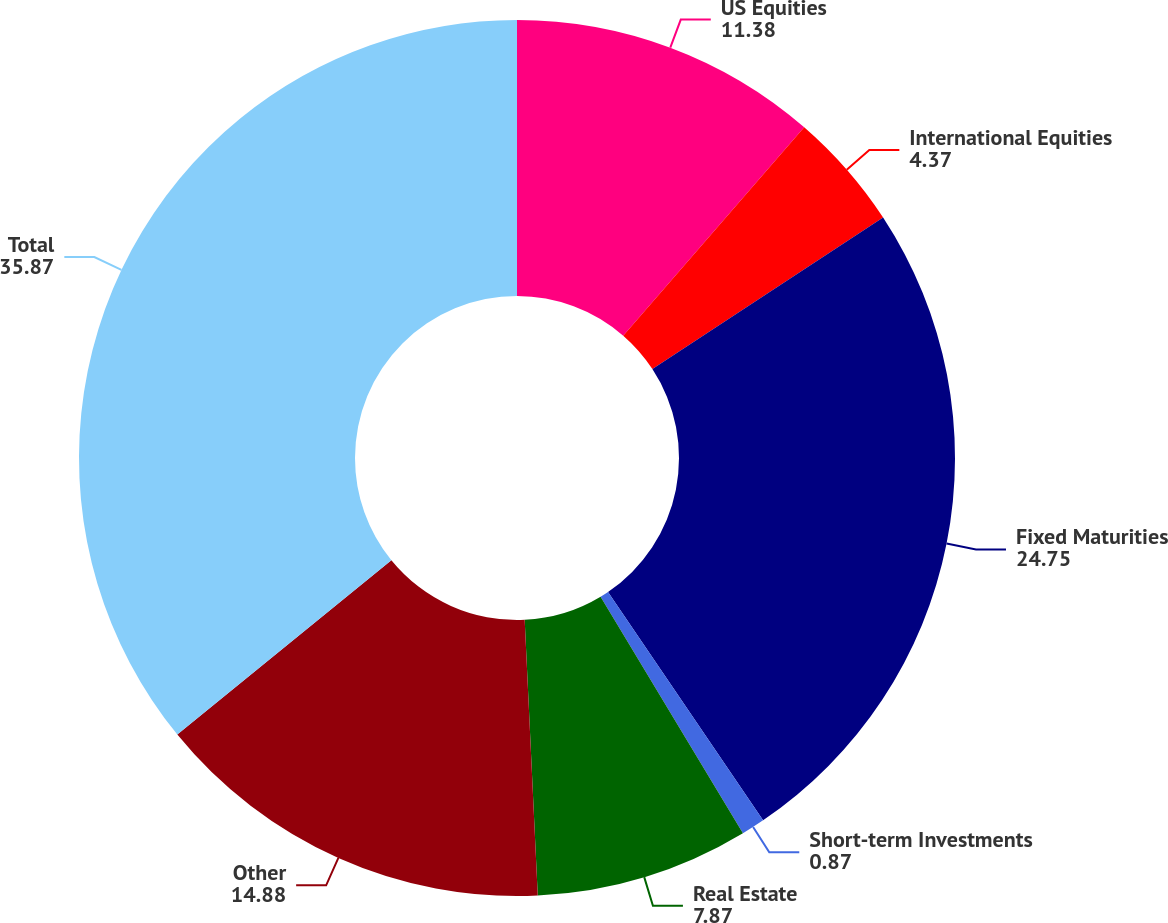Convert chart to OTSL. <chart><loc_0><loc_0><loc_500><loc_500><pie_chart><fcel>US Equities<fcel>International Equities<fcel>Fixed Maturities<fcel>Short-term Investments<fcel>Real Estate<fcel>Other<fcel>Total<nl><fcel>11.38%<fcel>4.37%<fcel>24.75%<fcel>0.87%<fcel>7.87%<fcel>14.88%<fcel>35.87%<nl></chart> 